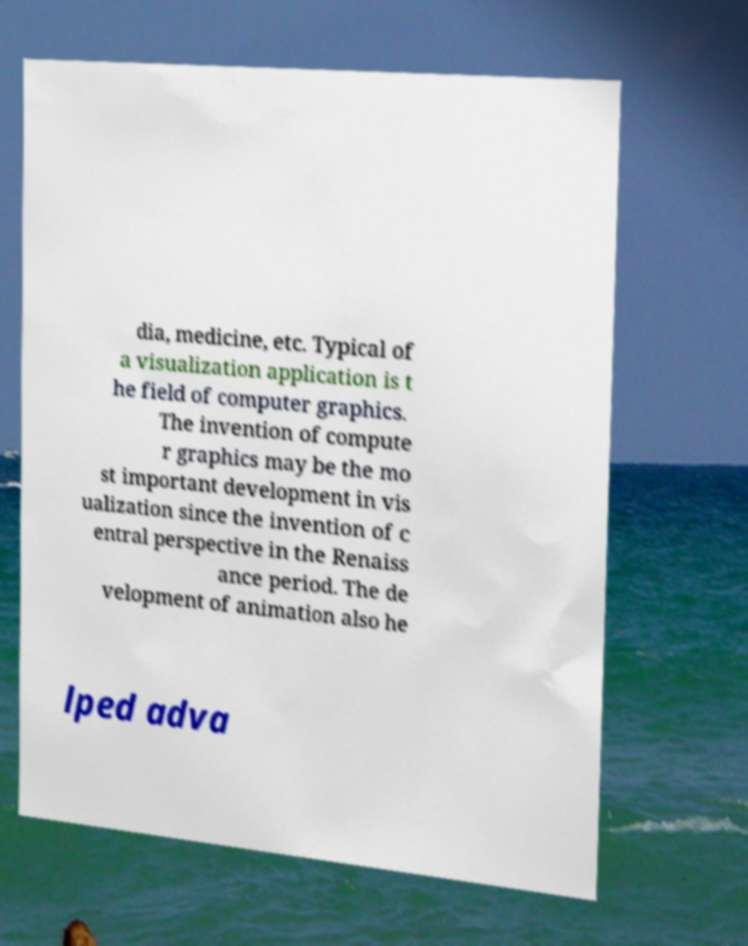I need the written content from this picture converted into text. Can you do that? dia, medicine, etc. Typical of a visualization application is t he field of computer graphics. The invention of compute r graphics may be the mo st important development in vis ualization since the invention of c entral perspective in the Renaiss ance period. The de velopment of animation also he lped adva 